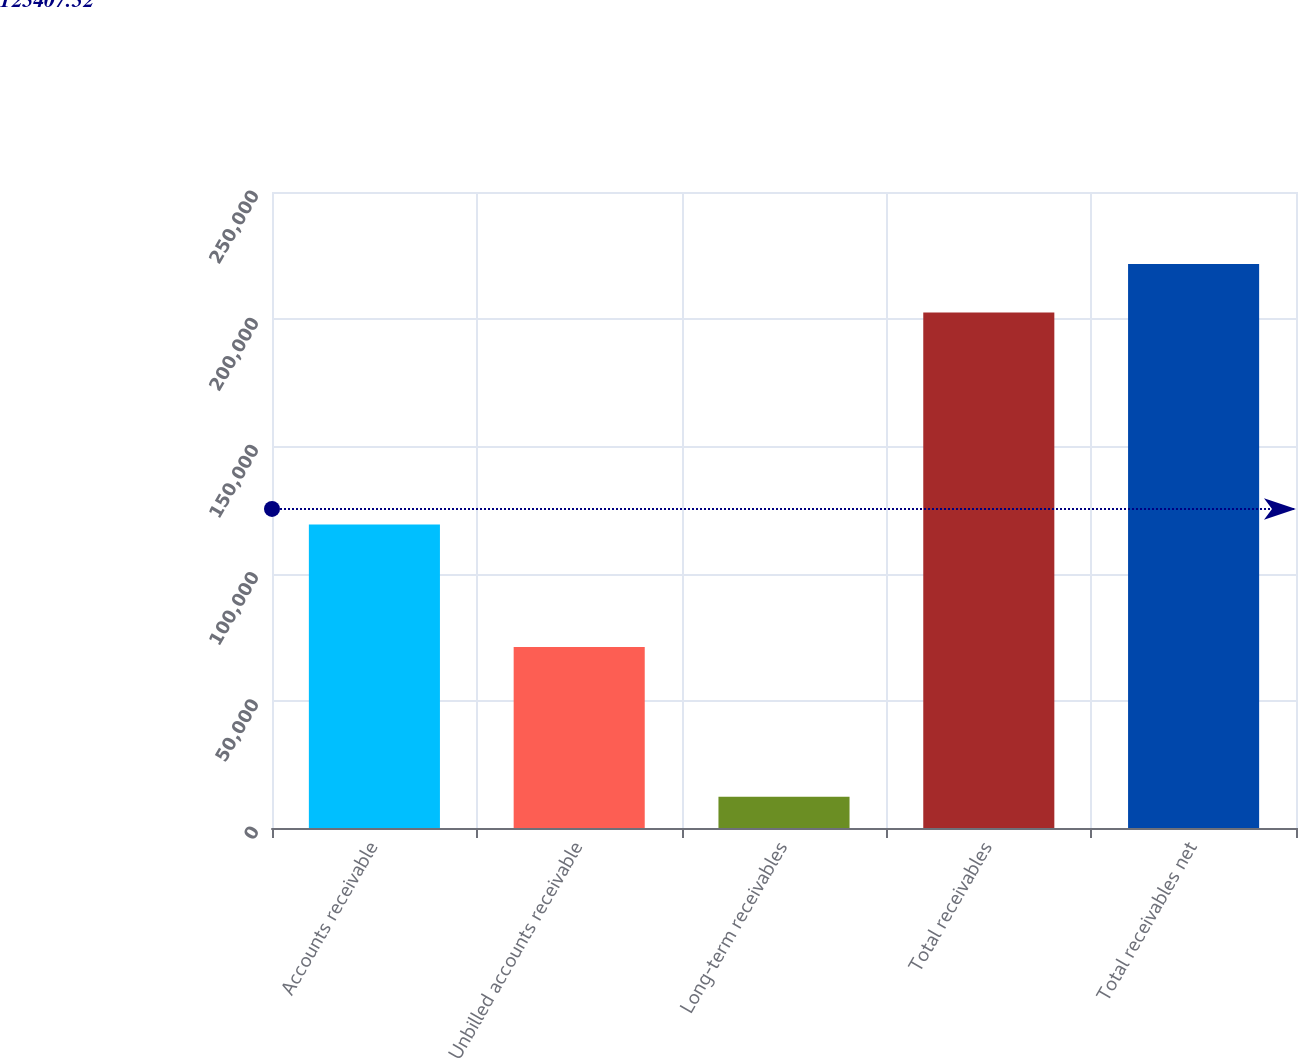Convert chart to OTSL. <chart><loc_0><loc_0><loc_500><loc_500><bar_chart><fcel>Accounts receivable<fcel>Unbilled accounts receivable<fcel>Long-term receivables<fcel>Total receivables<fcel>Total receivables net<nl><fcel>119325<fcel>71101<fcel>12239<fcel>202665<fcel>221708<nl></chart> 